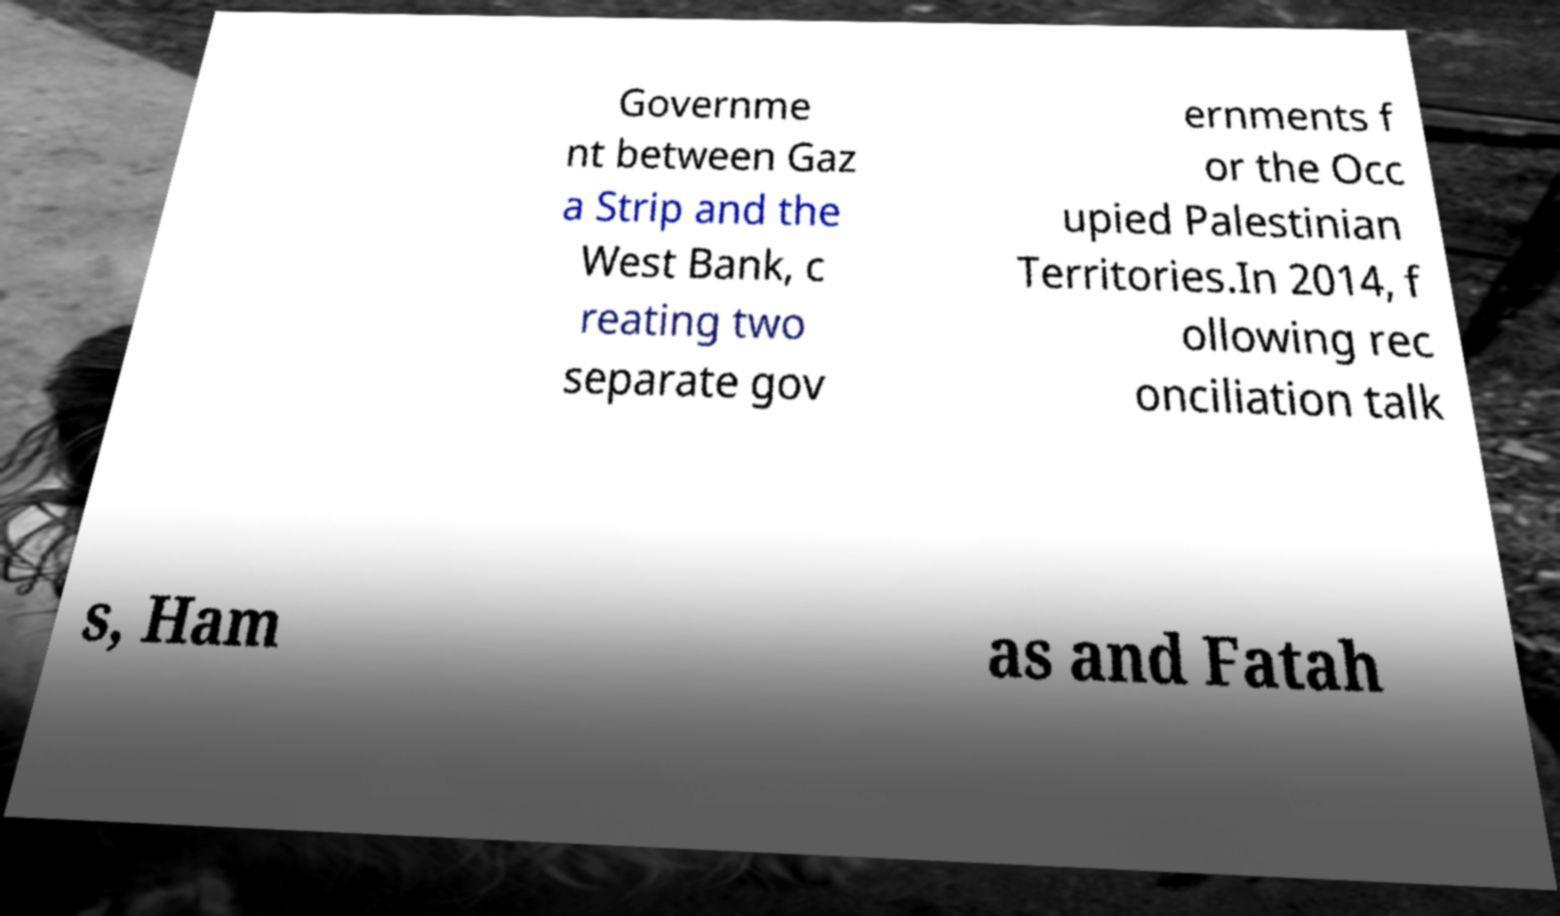Can you accurately transcribe the text from the provided image for me? Governme nt between Gaz a Strip and the West Bank, c reating two separate gov ernments f or the Occ upied Palestinian Territories.In 2014, f ollowing rec onciliation talk s, Ham as and Fatah 